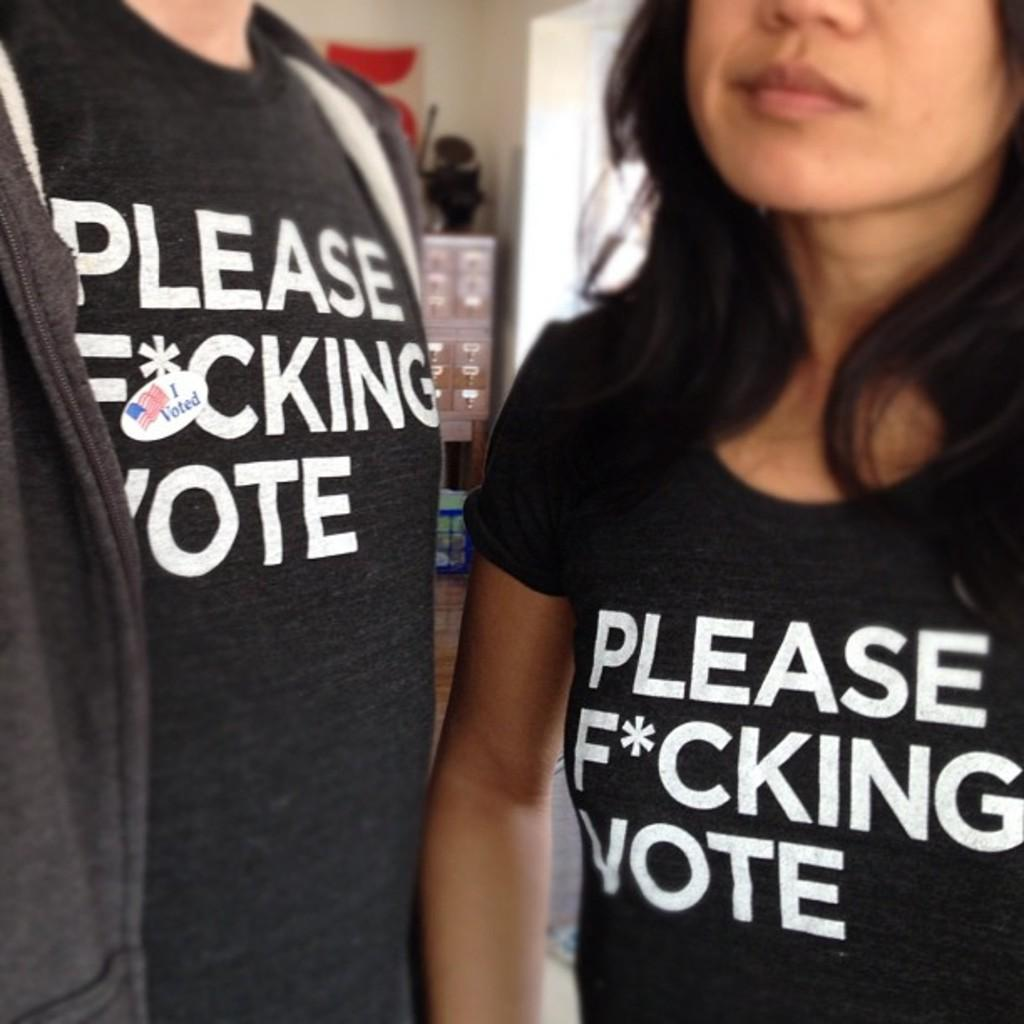<image>
Render a clear and concise summary of the photo. Shirts that are telling you to definetly vote. 